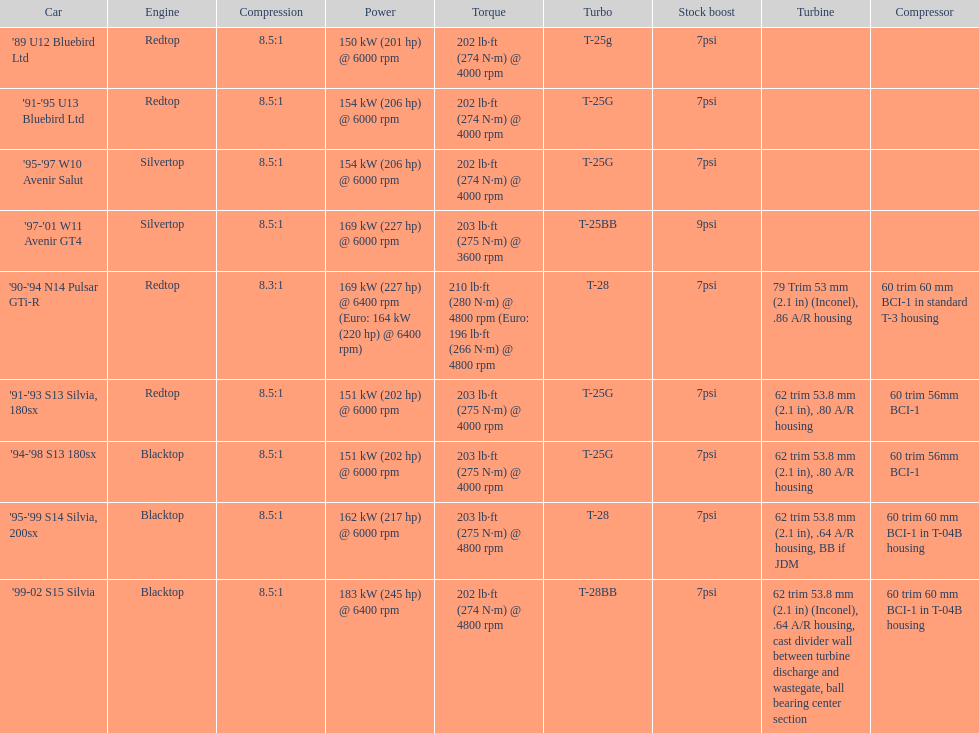Which car's power measured at higher than 6000 rpm? '90-'94 N14 Pulsar GTi-R, '99-02 S15 Silvia. 